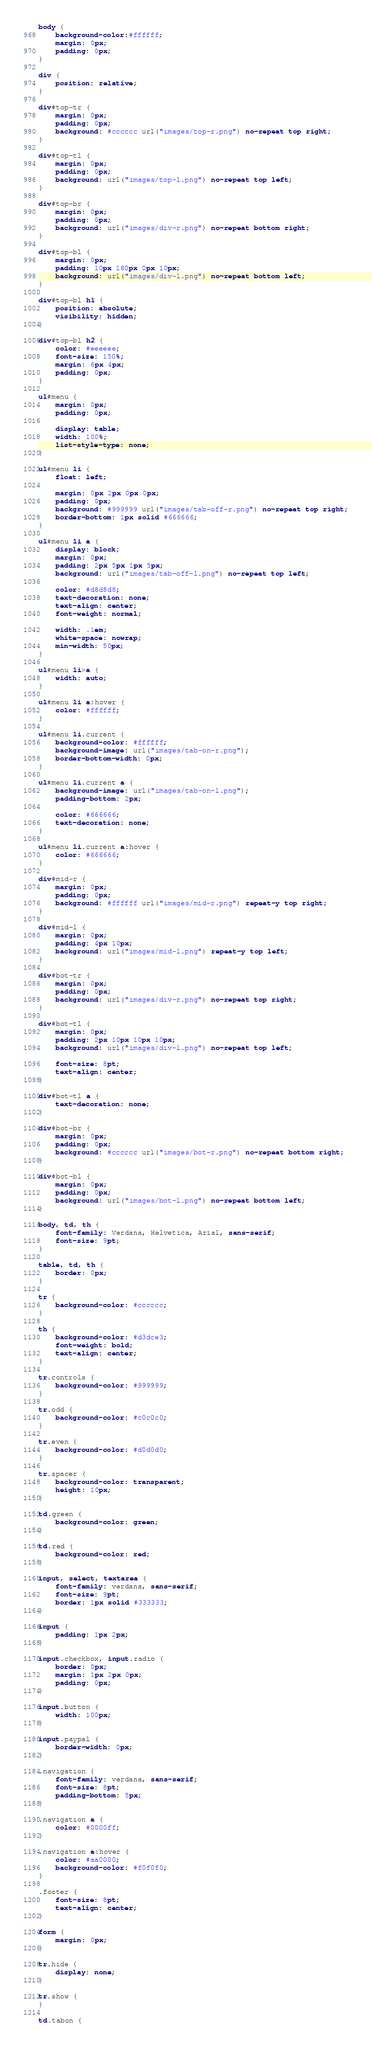Convert code to text. <code><loc_0><loc_0><loc_500><loc_500><_CSS_>body {
	background-color:#ffffff;
	margin: 0px;
	padding: 0px;
}

div {
	position: relative;
}

div#top-tr {
	margin: 0px;
	padding: 0px;
	background: #cccccc url("images/top-r.png") no-repeat top right;
}

div#top-tl {
	margin: 0px;
	padding: 0px;
	background: url("images/top-l.png") no-repeat top left;
}

div#top-br {
	margin: 0px;
	padding: 0px;
	background: url("images/div-r.png") no-repeat bottom right;
}

div#top-bl {
	margin: 0px;
	padding: 10px 180px 0px 10px;
	background: url("images/div-l.png") no-repeat bottom left;
}

div#top-bl h1 {
	position: absolute;
	visibility: hidden;
}

div#top-bl h2 {
	color: #eeeeee;
	font-size: 150%;
	margin: 6px 4px;
	padding: 0px;
}

ul#menu {
	margin: 0px;
	padding: 0px;
	
	display: table;
	width: 100%;
	list-style-type: none;
}

ul#menu li {
	float: left;
	
	margin: 0px 2px 0px 0px;
	padding: 0px;
	background: #999999 url("images/tab-off-r.png") no-repeat top right;
	border-bottom: 1px solid #666666;
}

ul#menu li a {
	display: block;
	margin: 0px;
	padding: 2px 5px 1px 5px;
	background: url("images/tab-off-l.png") no-repeat top left;
	
	color: #d8d8d8;
	text-decoration: none;
	text-align: center;
	font-weight: normal;
	
	width: .1em;
	white-space: nowrap;
	min-width: 50px;
}

ul#menu li>a {
	width: auto;
}

ul#menu li a:hover {
	color: #ffffff;
}

ul#menu li.current {
	background-color: #ffffff;
	background-image: url("images/tab-on-r.png");
	border-bottom-width: 0px;
}

ul#menu li.current a {
	background-image: url("images/tab-on-l.png");
	padding-bottom: 2px;
	
	color: #666666;
	text-decoration: none;
}

ul#menu li.current a:hover {
	color: #666666;
}

div#mid-r {
	margin: 0px;
	padding: 0px;
	background: #ffffff url("images/mid-r.png") repeat-y top right;
}

div#mid-l {
	margin: 0px;
	padding: 4px 10px;
	background: url("images/mid-l.png") repeat-y top left;
}

div#bot-tr {
	margin: 0px;
	padding: 0px;
	background: url("images/div-r.png") no-repeat top right;
}

div#bot-tl {
	margin: 0px;
	padding: 2px 10px 10px 10px;
	background: url("images/div-l.png") no-repeat top left;
	
	font-size: 8pt;
	text-align: center;
}

div#bot-tl a {
	text-decoration: none;
}

div#bot-br {
	margin: 0px;
	padding: 0px;
	background: #cccccc url("images/bot-r.png") no-repeat bottom right;
}

div#bot-bl {
	margin: 0px;
	padding: 0px;
	background: url("images/bot-l.png") no-repeat bottom left;
}

body, td, th {
	font-family: Verdana, Helvetica, Arial, sans-serif;
	font-size: 9pt;
}

table, td, th {
	border: 0px;
}

tr {
	background-color: #cccccc;
}

th {
	background-color: #d3dce3;
	font-weight: bold;
	text-align: center;
}

tr.controls {
	background-color: #999999;
}

tr.odd {
	background-color: #c0c0c0;
}

tr.even {
	background-color: #d0d0d0;
}

tr.spacer {
	background-color: transparent;
	height: 10px;
}

td.green {
	background-color: green;
}

td.red {
	background-color: red;
}

input, select, textarea {
	font-family: verdana, sans-serif;
	font-size: 9pt;
	border: 1px solid #333333;
}

input {
	padding: 1px 2px;
}

input.checkbox, input.radio {
	border: 0px;
	margin: 1px 2px 0px;
	padding: 0px;
}

input.button {
	width: 100px;
}

input.paypal {
	border-width: 0px;
}

.navigation {
	font-family: verdana, sans-serif;
	font-size: 8pt;
	padding-bottom: 5px;
}

.navigation a {
	color: #0000ff;
}

.navigation a:hover {
	color: #aa0000;
	background-color: #f0f0f0;
}

.footer {
	font-size: 8pt;
	text-align: center;
}

form {
	margin: 0px;
}

tr.hide {
	display: none;
}

tr.show {
}

td.tabon {</code> 